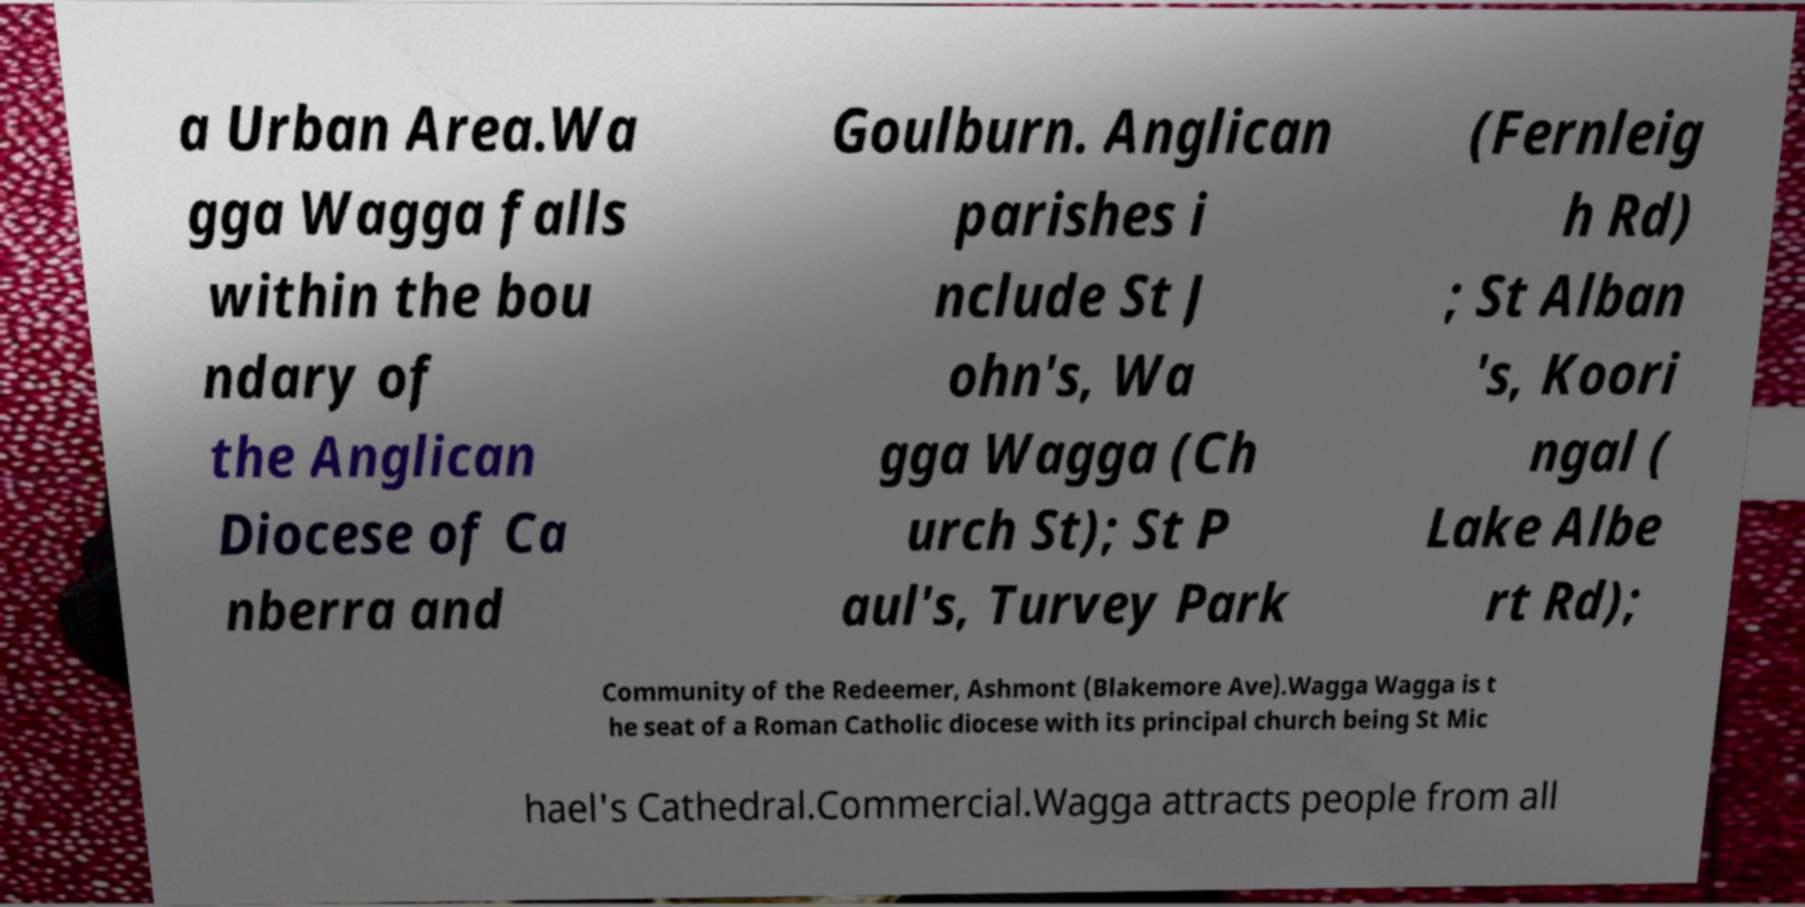Please read and relay the text visible in this image. What does it say? a Urban Area.Wa gga Wagga falls within the bou ndary of the Anglican Diocese of Ca nberra and Goulburn. Anglican parishes i nclude St J ohn's, Wa gga Wagga (Ch urch St); St P aul's, Turvey Park (Fernleig h Rd) ; St Alban 's, Koori ngal ( Lake Albe rt Rd); Community of the Redeemer, Ashmont (Blakemore Ave).Wagga Wagga is t he seat of a Roman Catholic diocese with its principal church being St Mic hael's Cathedral.Commercial.Wagga attracts people from all 